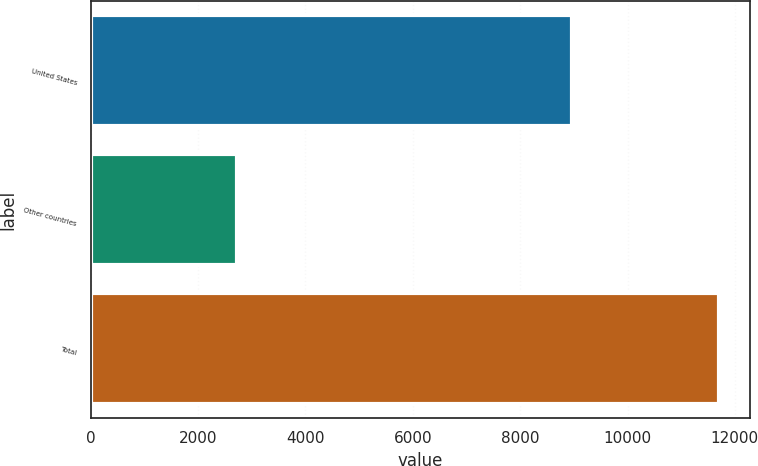<chart> <loc_0><loc_0><loc_500><loc_500><bar_chart><fcel>United States<fcel>Other countries<fcel>Total<nl><fcel>8966.9<fcel>2733.5<fcel>11700.4<nl></chart> 